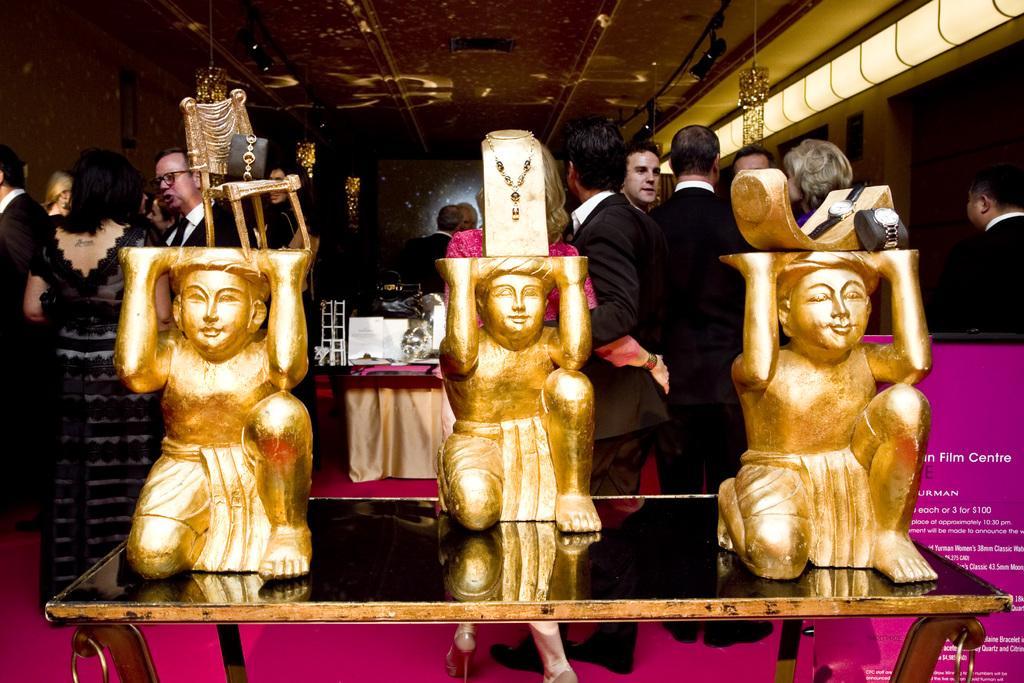Describe this image in one or two sentences. In this picture I can see there is a table here and there are three statues on the table and they are in golden color and there are necklaces, watches and bracelets placed on them. IN the backdrop there are a group of people standing on to left and there is a woman here, she is wearing a black dress and there is another group of people standing at right side, there is a woman wearing a pink dress, there are lights attached to the ceiling and there is a banner on to right. 